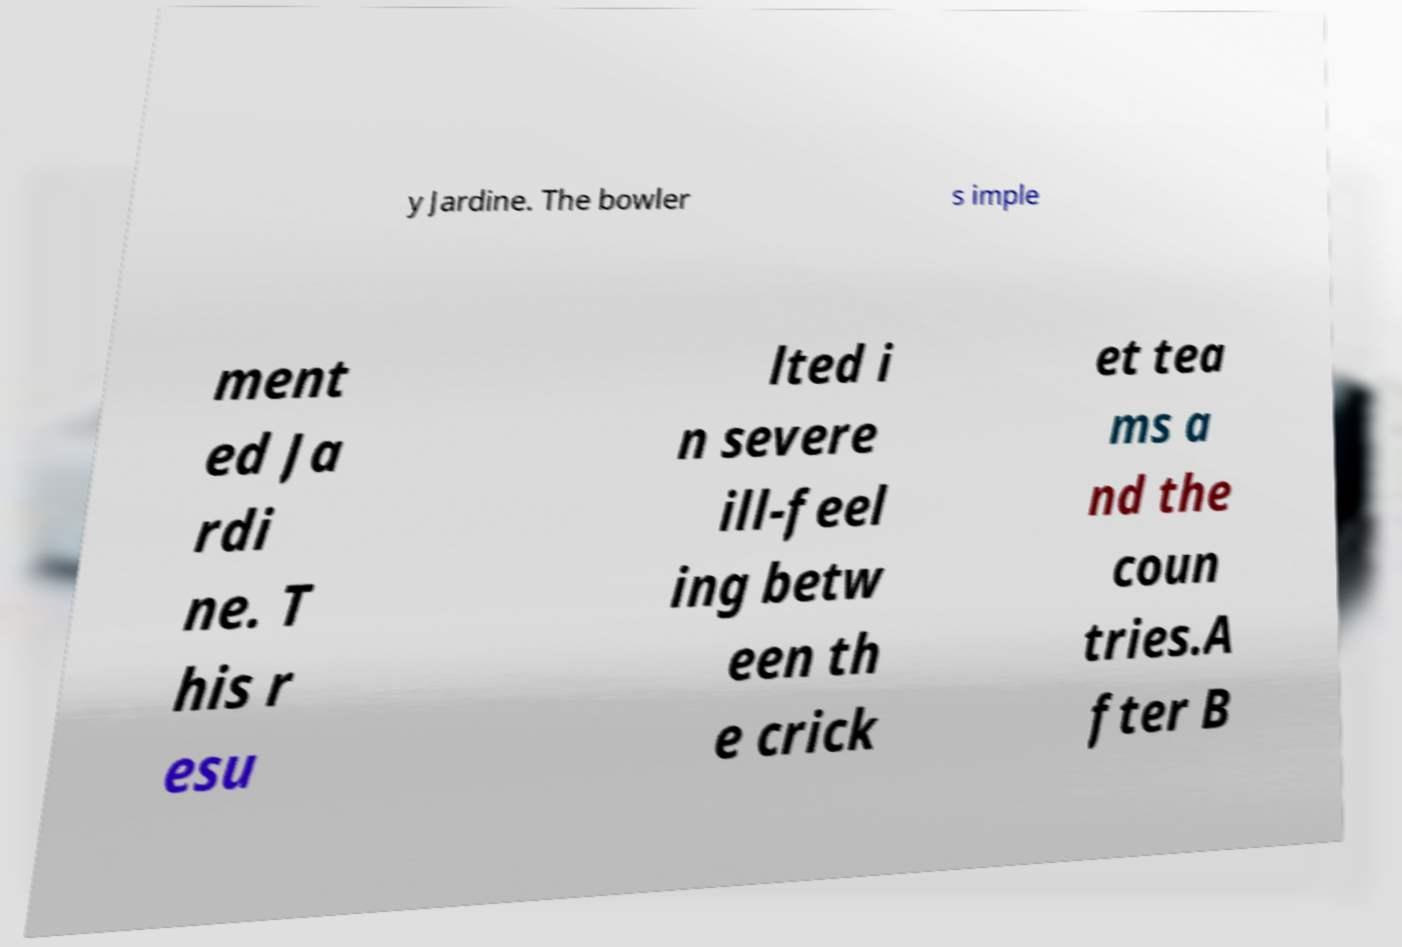Please read and relay the text visible in this image. What does it say? y Jardine. The bowler s imple ment ed Ja rdi ne. T his r esu lted i n severe ill-feel ing betw een th e crick et tea ms a nd the coun tries.A fter B 